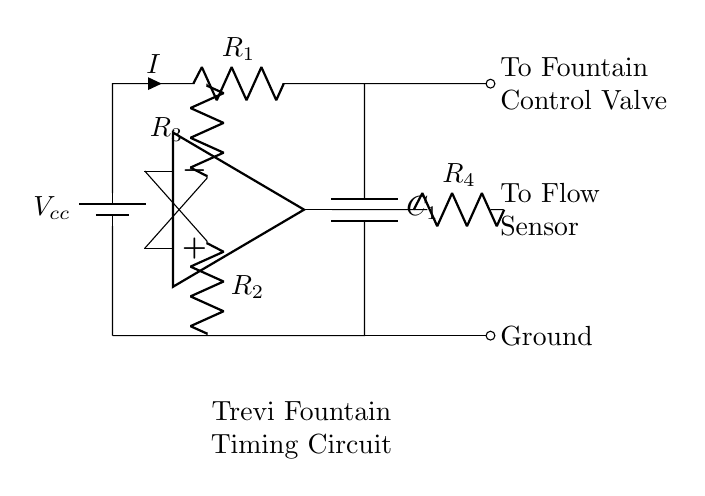What is the power source for this circuit? The power source is represented by the battery labeled Vcc, which provides the necessary voltage for the circuit operation.
Answer: Vcc What is the total number of resistors in the circuit? There are four resistors indicated in the circuit diagram, labeled as R1, R2, R3, and R4.
Answer: Four Which component regulates the water flow to the fountain? The component that regulates the water flow is labeled "To Fountain Control Valve," which is connected to the output of the first capacitor in the circuit.
Answer: Fountain Control Valve What is the purpose of the op-amp in this circuit? The op-amp acts as a voltage comparator, amplifying the difference between its two input voltages, which helps to control the timing of the water flow through the circuit based on the sensor input.
Answer: Voltage comparator How does the water flow regulation relate to the flow sensor? The output from the op-amp is connected to a resistor leading to the flow sensor which indicates whether the water is flowing, thus controlling how the valve opens or closes based on sensor feedback.
Answer: Feedback control What are the components connected to the positive and negative inputs of the op-amp? The positive input of the op-amp is connected to resistor R3 and the negative input is connected to resistor R2, which sets the reference voltage for comparison.
Answer: R3 and R2 What is the significance of the capacitor in the timing circuit? The capacitor (C1) is significant as it determines the timing characteristics by charging and discharging, which can create delays in the circuit operation, influencing how long the water flows.
Answer: Timing mechanism 